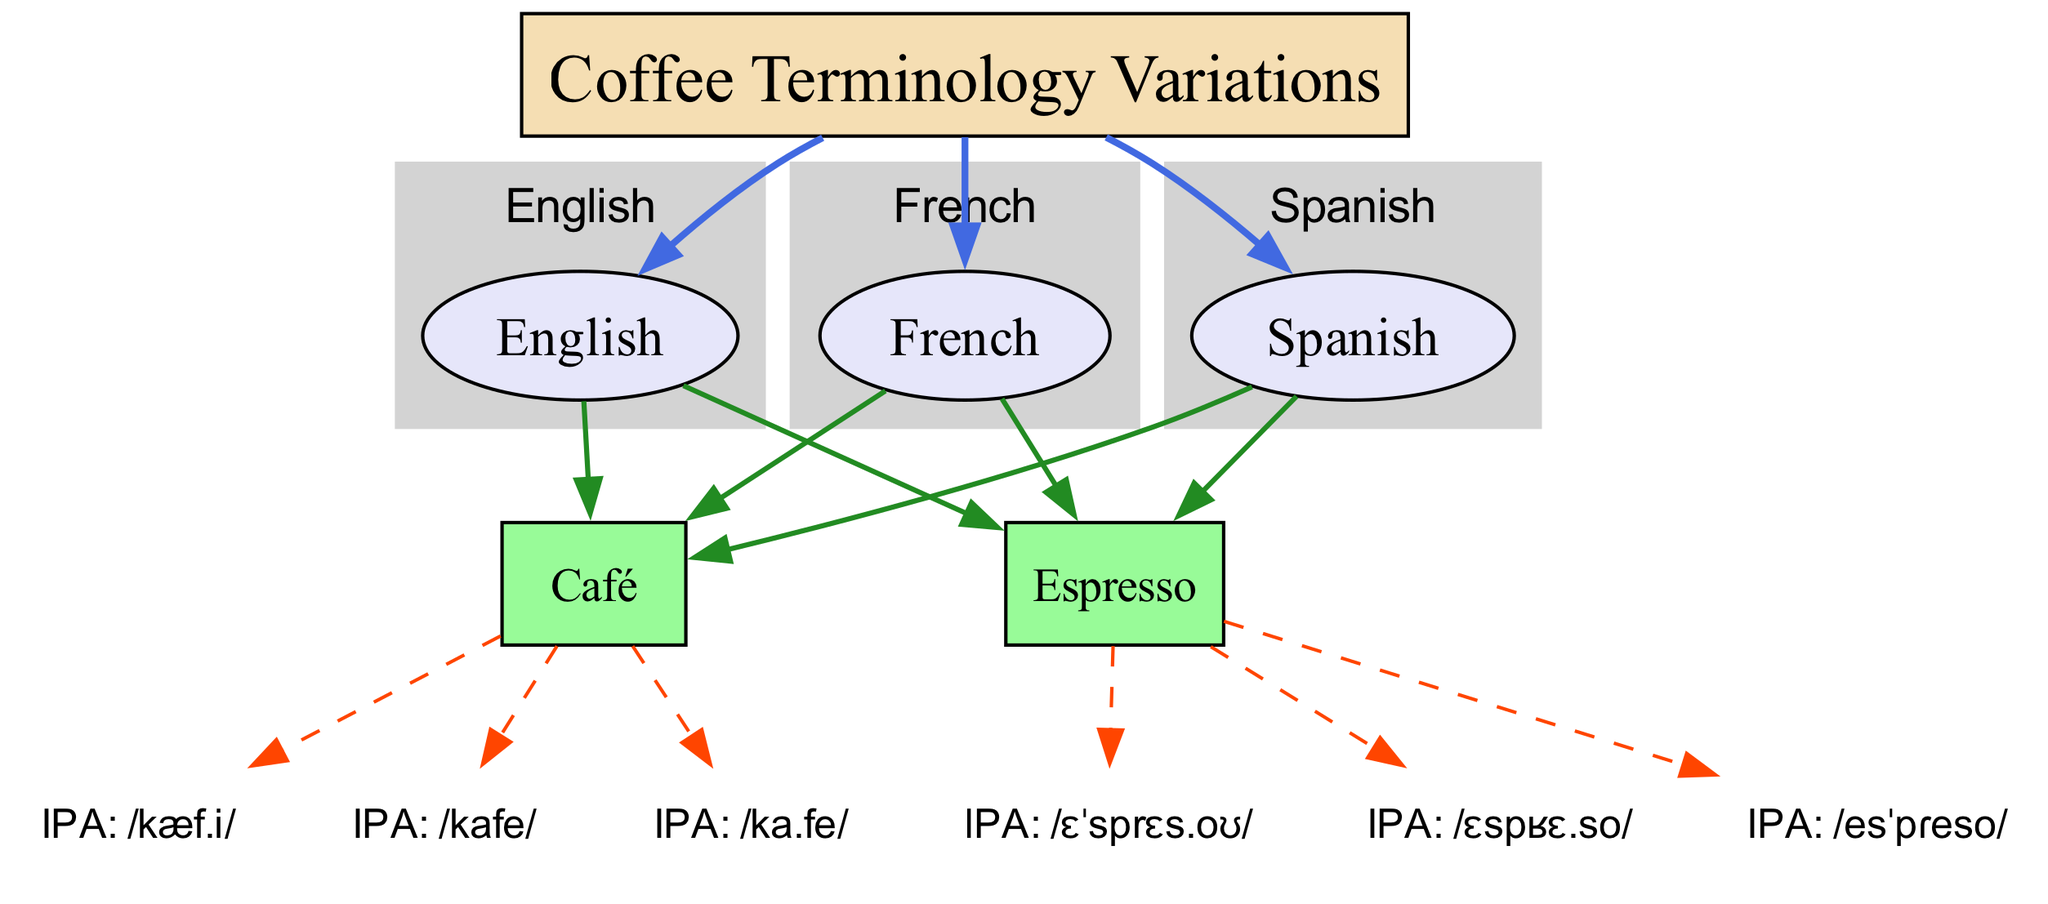What are the IPA transcriptions for “Café” in English? From the diagram, locate the node labeled “Café” under the English language node. The connected phonetic nodes provide the IPA transcription for café in English, which is /kæf.i/.
Answer: /kæf.i/ How many language nodes are present in the diagram? Count the nodes labeled as languages in the diagram. There are three languages: English, French, and Spanish.
Answer: 3 What is the IPA transcription for “Espresso” in French? Find the “Espresso” term node under the French language node. The related phonetic node provides the IPA transcription for espresso in French, which is /ɛspʁɛ.so/.
Answer: /ɛspʁɛ.so/ Which term has the IPA transcription /esˈpɾeso/? Identify the phonetic node with the transcription /esˈpɾeso/, then trace back to which term it describes. This transcription corresponds to the term “Espresso” under the Spanish language node.
Answer: Espresso What is the relationship type between language nodes and terminology nodes? Analyze the connections from language nodes to the terminology nodes. The relationship type indicated in the diagram is "contains."
Answer: contains How many terms are described in the diagram? Review the nodes categorized as terms. There are two terms: “Café” and “Espresso.”
Answer: 2 What is the phonetic transcription of "Café" in Spanish? Locate the Spanish language node and find the term “Café.” Then refer to the connected phonetic node for its transcription, which is /ka.fe/.
Answer: /ka.fe/ Which language shows the transcription /ɛˈsprɛs.o/? Look at the phonetic transcriptions connected to the term “Espresso” and check under which language node this transcription appears. It is associated with the English language node.
Answer: English What color represents the main node in the diagram? Check the styling attributes for the node labeled “Coffee Terminology Variations,” which are specified to have a fill color of #F5DEB3.
Answer: #F5DEB3 